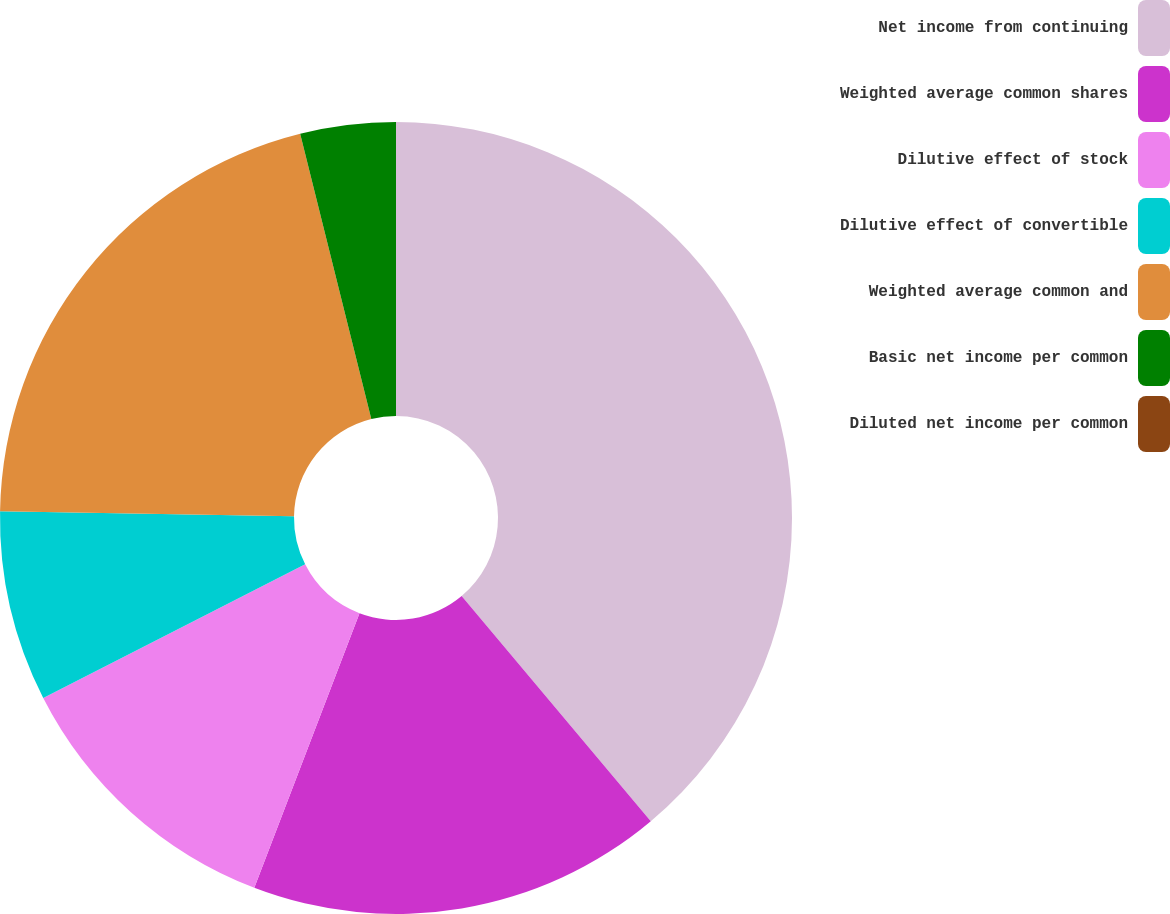Convert chart to OTSL. <chart><loc_0><loc_0><loc_500><loc_500><pie_chart><fcel>Net income from continuing<fcel>Weighted average common shares<fcel>Dilutive effect of stock<fcel>Dilutive effect of convertible<fcel>Weighted average common and<fcel>Basic net income per common<fcel>Diluted net income per common<nl><fcel>38.88%<fcel>16.95%<fcel>11.67%<fcel>7.78%<fcel>20.84%<fcel>3.89%<fcel>0.0%<nl></chart> 